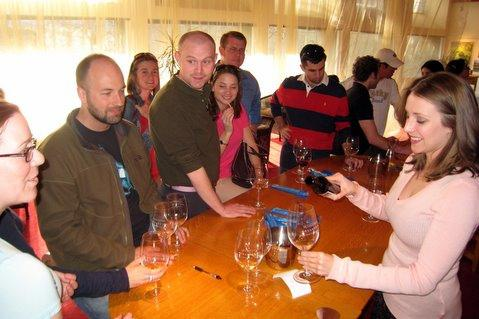What kind of event is this? Please explain your reasoning. party. People are being together with drinks. 